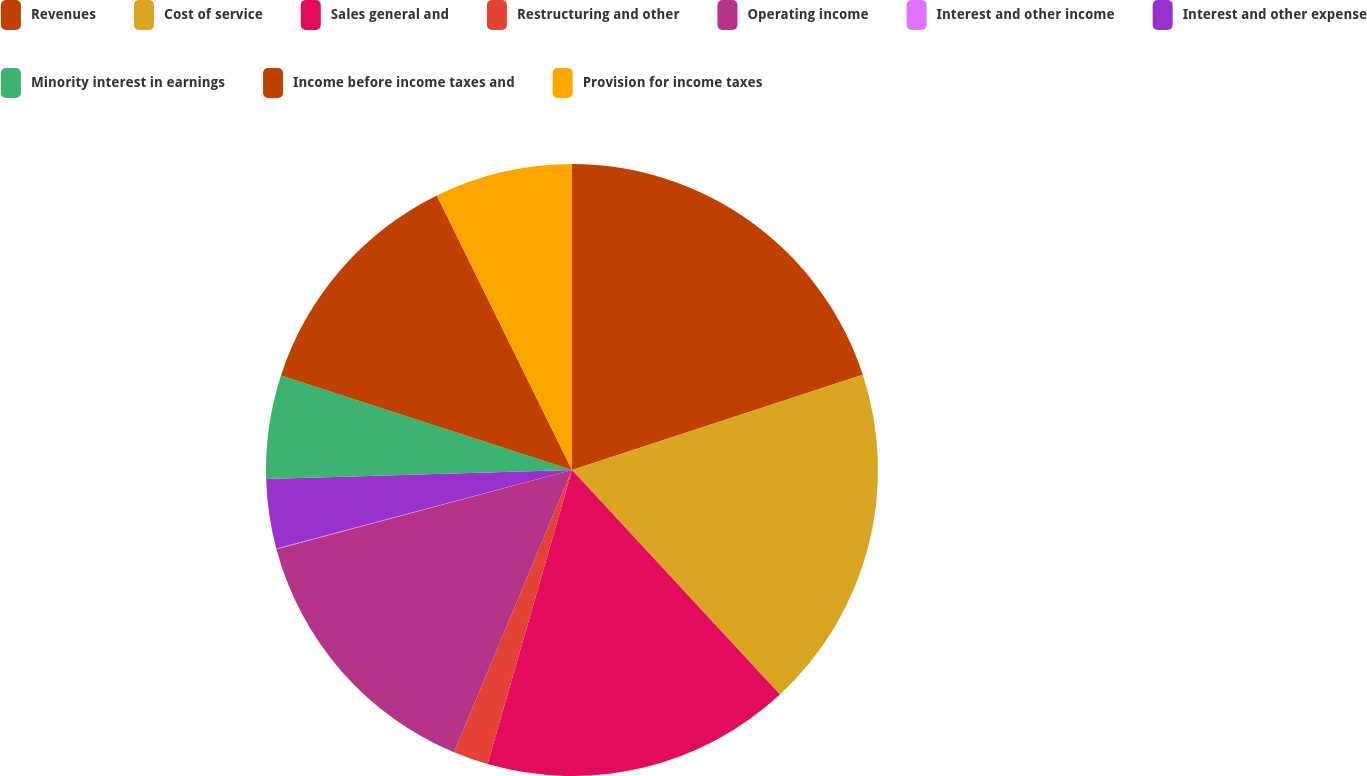Convert chart. <chart><loc_0><loc_0><loc_500><loc_500><pie_chart><fcel>Revenues<fcel>Cost of service<fcel>Sales general and<fcel>Restructuring and other<fcel>Operating income<fcel>Interest and other income<fcel>Interest and other expense<fcel>Minority interest in earnings<fcel>Income before income taxes and<fcel>Provision for income taxes<nl><fcel>19.96%<fcel>18.15%<fcel>16.34%<fcel>1.85%<fcel>14.53%<fcel>0.04%<fcel>3.66%<fcel>5.47%<fcel>12.72%<fcel>7.28%<nl></chart> 